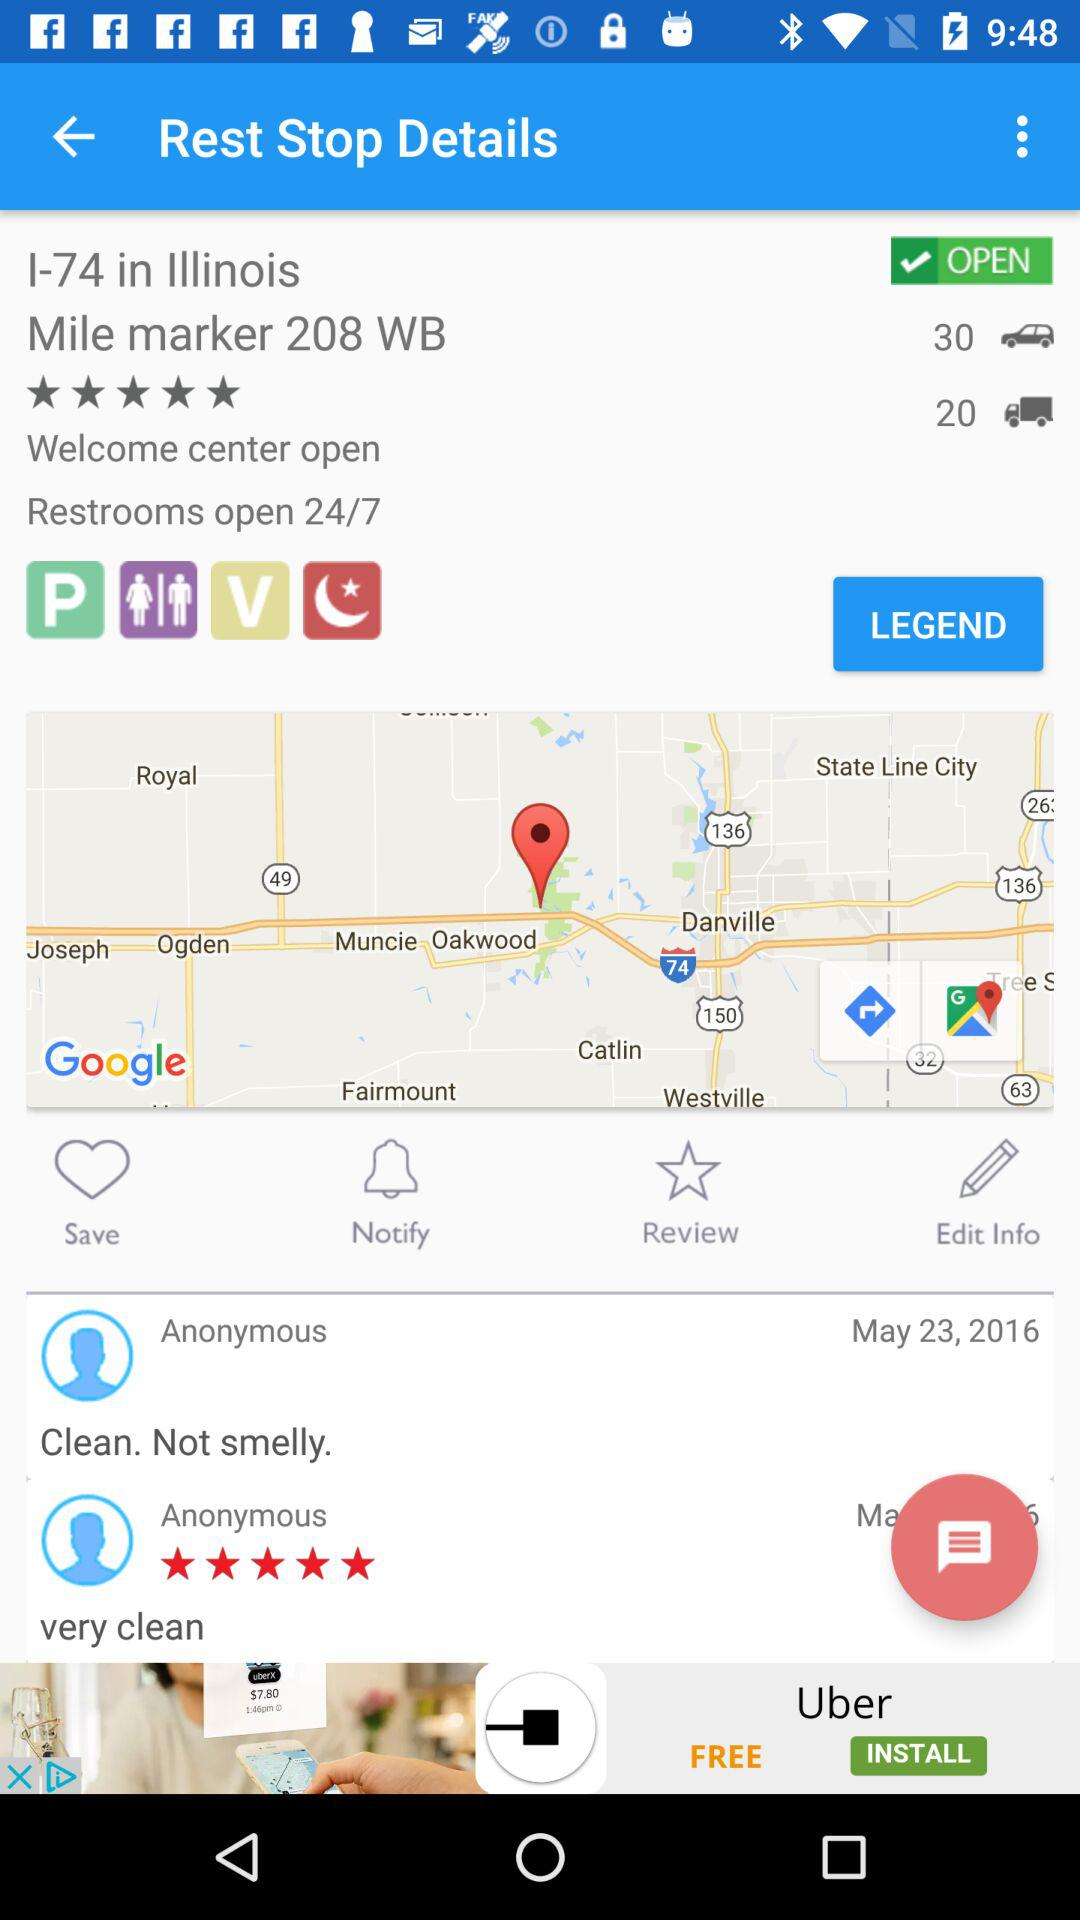What is the star rating for I-74 in Illinois? The rating is 5 stars. 